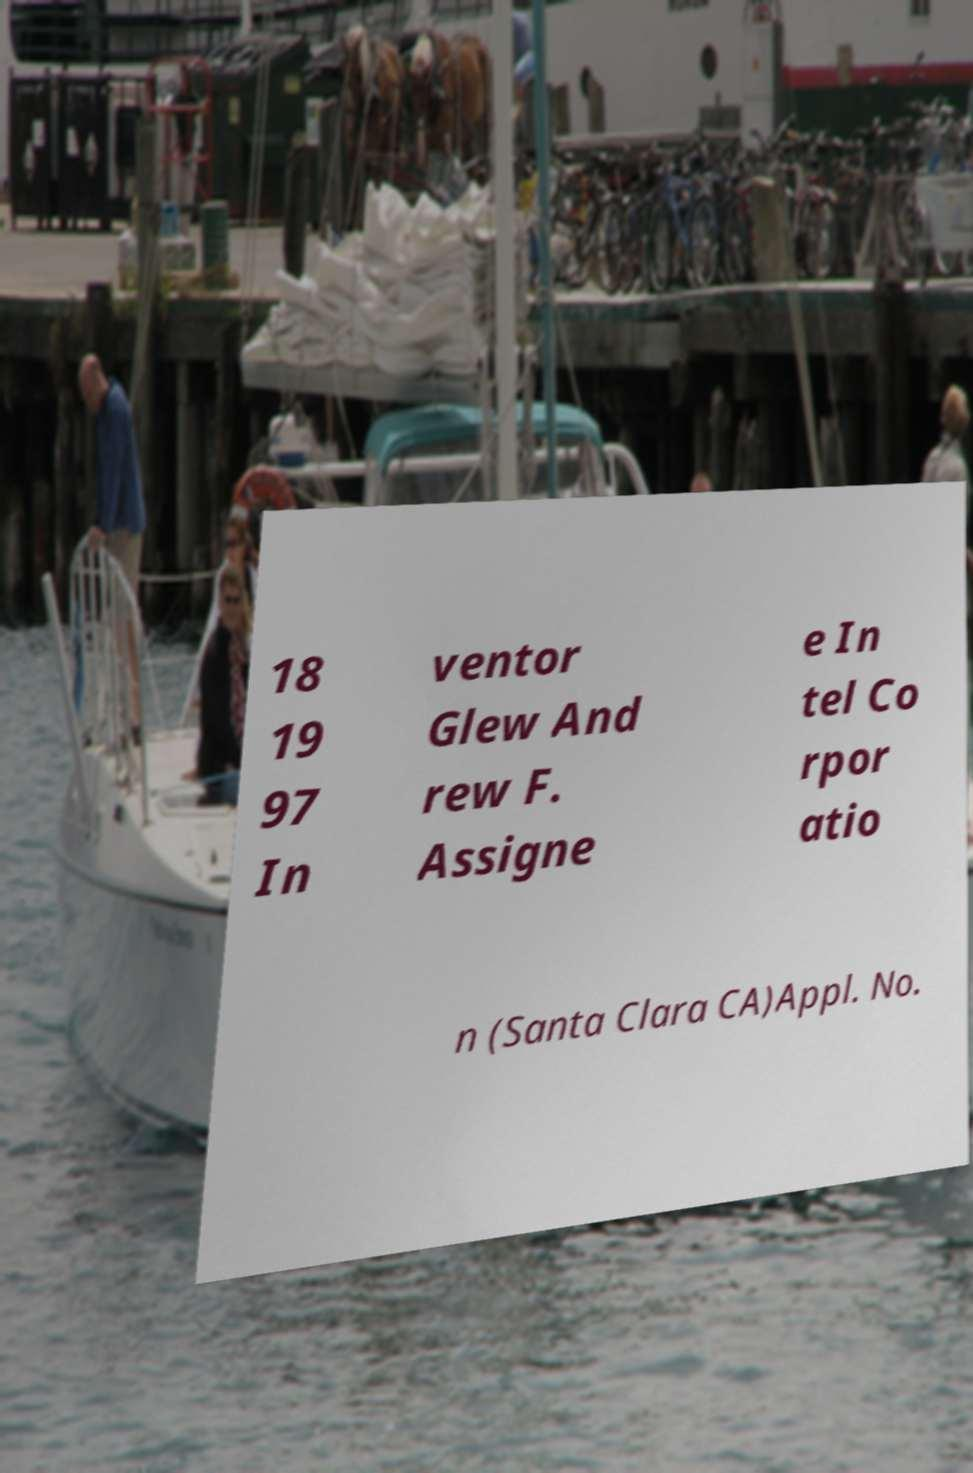I need the written content from this picture converted into text. Can you do that? 18 19 97 In ventor Glew And rew F. Assigne e In tel Co rpor atio n (Santa Clara CA)Appl. No. 